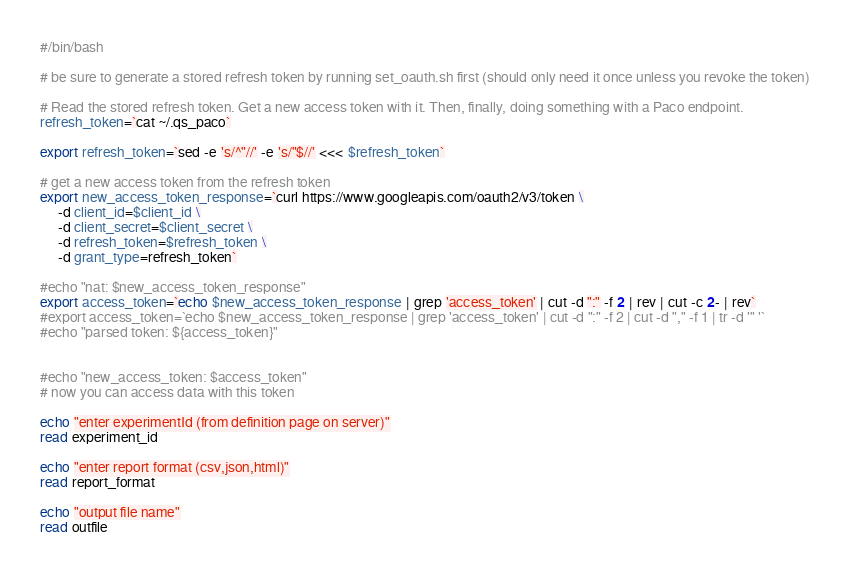<code> <loc_0><loc_0><loc_500><loc_500><_Bash_>#/bin/bash

# be sure to generate a stored refresh token by running set_oauth.sh first (should only need it once unless you revoke the token)

# Read the stored refresh token. Get a new access token with it. Then, finally, doing something with a Paco endpoint.
refresh_token=`cat ~/.qs_paco`

export refresh_token=`sed -e 's/^"//' -e 's/"$//' <<< $refresh_token`

# get a new access token from the refresh token
export new_access_token_response=`curl https://www.googleapis.com/oauth2/v3/token \
     -d client_id=$client_id \
     -d client_secret=$client_secret \
     -d refresh_token=$refresh_token \
     -d grant_type=refresh_token`

#echo "nat: $new_access_token_response"
export access_token=`echo $new_access_token_response | grep 'access_token' | cut -d ":" -f 2 | rev | cut -c 2- | rev`
#export access_token=`echo $new_access_token_response | grep 'access_token' | cut -d ":" -f 2 | cut -d "," -f 1 | tr -d '" '`
#echo "parsed token: ${access_token}"


#echo "new_access_token: $access_token"
# now you can access data with this token

echo "enter experimentId (from definition page on server)"
read experiment_id

echo "enter report format (csv,json,html)"
read report_format
 
echo "output file name"
read outfile
</code> 